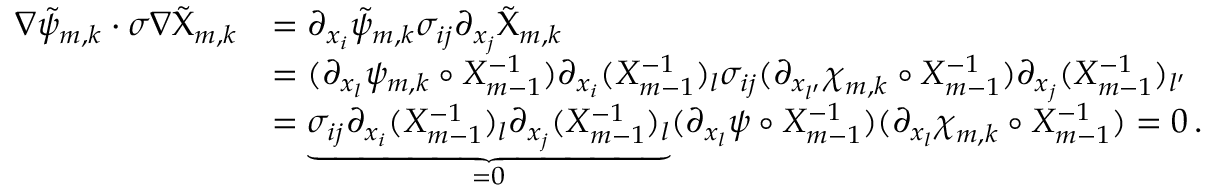<formula> <loc_0><loc_0><loc_500><loc_500>\begin{array} { r l } { \nabla \tilde { \psi } _ { m , k } \cdot \sigma \nabla \tilde { \chi } _ { m , k } } & { = \partial _ { x _ { i } } \tilde { \psi } _ { m , k } \sigma _ { i j } \partial _ { x _ { j } } \tilde { \chi } _ { m , k } } \\ & { = ( \partial _ { x _ { l } } \psi _ { m , k } \circ X _ { m - 1 } ^ { - 1 } ) \partial _ { x _ { i } } ( X _ { m - 1 } ^ { - 1 } ) _ { l } \sigma _ { i j } ( \partial _ { x _ { l ^ { \prime } } } { \chi } _ { m , k } \circ X _ { m - 1 } ^ { - 1 } ) \partial _ { x _ { j } } ( X _ { m - 1 } ^ { - 1 } ) _ { l ^ { \prime } } } \\ & { = \underbrace { \sigma _ { i j } \partial _ { x _ { i } } ( X _ { m - 1 } ^ { - 1 } ) _ { l } \partial _ { x _ { j } } ( X _ { m - 1 } ^ { - 1 } ) _ { l } } _ { = 0 } ( \partial _ { x _ { l } } \psi \circ X _ { m - 1 } ^ { - 1 } ) ( \partial _ { x _ { l } } { \chi } _ { m , k } \circ X _ { m - 1 } ^ { - 1 } ) = 0 \, . } \end{array}</formula> 